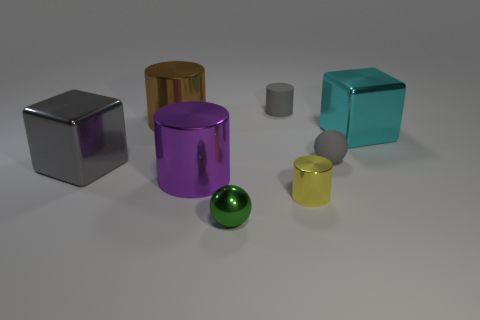How many objects are green matte things or cyan metal objects?
Keep it short and to the point. 1. There is a cyan thing; does it have the same shape as the small thing in front of the yellow cylinder?
Provide a short and direct response. No. The tiny green object that is to the right of the big purple thing has what shape?
Ensure brevity in your answer.  Sphere. Is the cyan metallic object the same shape as the big brown metal thing?
Provide a short and direct response. No. What is the size of the other metallic thing that is the same shape as the large gray metallic object?
Make the answer very short. Large. Do the metallic cylinder in front of the purple object and the purple cylinder have the same size?
Offer a very short reply. No. There is a object that is in front of the purple metallic thing and behind the tiny metallic ball; how big is it?
Your answer should be very brief. Small. What is the material of the small cylinder that is the same color as the small matte ball?
Provide a succinct answer. Rubber. What number of matte things are the same color as the small matte cylinder?
Keep it short and to the point. 1. Are there an equal number of cubes to the right of the gray rubber cylinder and brown things?
Offer a very short reply. Yes. 